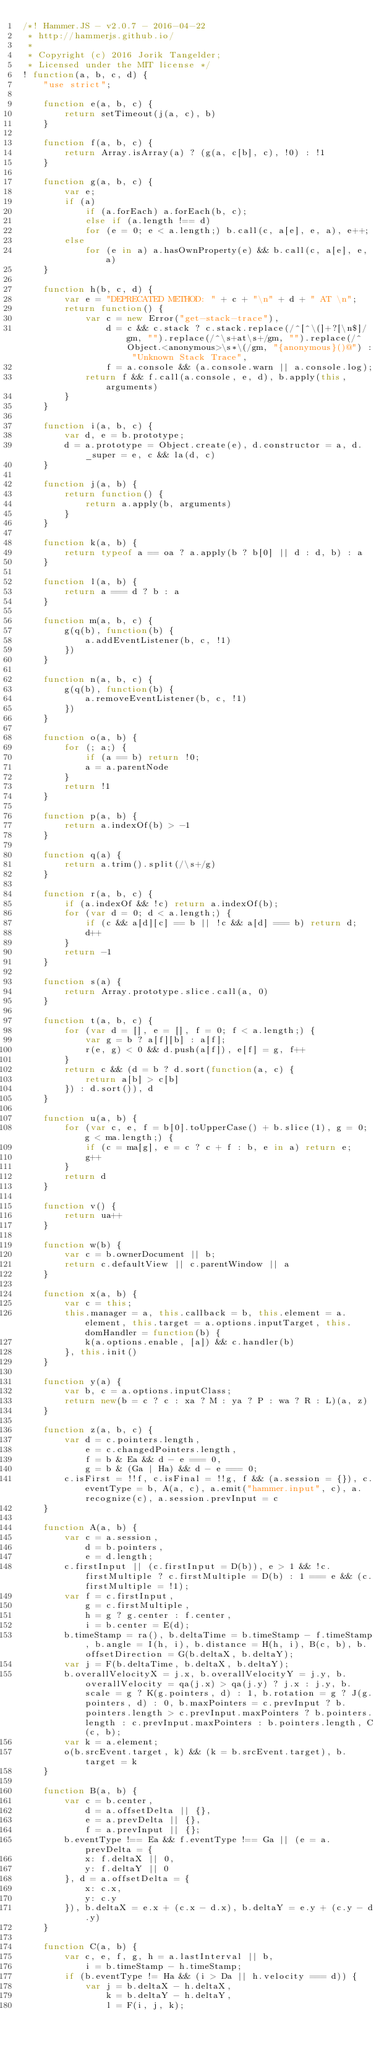<code> <loc_0><loc_0><loc_500><loc_500><_JavaScript_>/*! Hammer.JS - v2.0.7 - 2016-04-22
 * http://hammerjs.github.io/
 *
 * Copyright (c) 2016 Jorik Tangelder;
 * Licensed under the MIT license */
! function(a, b, c, d) {
    "use strict";

    function e(a, b, c) {
        return setTimeout(j(a, c), b)
    }

    function f(a, b, c) {
        return Array.isArray(a) ? (g(a, c[b], c), !0) : !1
    }

    function g(a, b, c) {
        var e;
        if (a)
            if (a.forEach) a.forEach(b, c);
            else if (a.length !== d)
            for (e = 0; e < a.length;) b.call(c, a[e], e, a), e++;
        else
            for (e in a) a.hasOwnProperty(e) && b.call(c, a[e], e, a)
    }

    function h(b, c, d) {
        var e = "DEPRECATED METHOD: " + c + "\n" + d + " AT \n";
        return function() {
            var c = new Error("get-stack-trace"),
                d = c && c.stack ? c.stack.replace(/^[^\(]+?[\n$]/gm, "").replace(/^\s+at\s+/gm, "").replace(/^Object.<anonymous>\s*\(/gm, "{anonymous}()@") : "Unknown Stack Trace",
                f = a.console && (a.console.warn || a.console.log);
            return f && f.call(a.console, e, d), b.apply(this, arguments)
        }
    }

    function i(a, b, c) {
        var d, e = b.prototype;
        d = a.prototype = Object.create(e), d.constructor = a, d._super = e, c && la(d, c)
    }

    function j(a, b) {
        return function() {
            return a.apply(b, arguments)
        }
    }

    function k(a, b) {
        return typeof a == oa ? a.apply(b ? b[0] || d : d, b) : a
    }

    function l(a, b) {
        return a === d ? b : a
    }

    function m(a, b, c) {
        g(q(b), function(b) {
            a.addEventListener(b, c, !1)
        })
    }

    function n(a, b, c) {
        g(q(b), function(b) {
            a.removeEventListener(b, c, !1)
        })
    }

    function o(a, b) {
        for (; a;) {
            if (a == b) return !0;
            a = a.parentNode
        }
        return !1
    }

    function p(a, b) {
        return a.indexOf(b) > -1
    }

    function q(a) {
        return a.trim().split(/\s+/g)
    }

    function r(a, b, c) {
        if (a.indexOf && !c) return a.indexOf(b);
        for (var d = 0; d < a.length;) {
            if (c && a[d][c] == b || !c && a[d] === b) return d;
            d++
        }
        return -1
    }

    function s(a) {
        return Array.prototype.slice.call(a, 0)
    }

    function t(a, b, c) {
        for (var d = [], e = [], f = 0; f < a.length;) {
            var g = b ? a[f][b] : a[f];
            r(e, g) < 0 && d.push(a[f]), e[f] = g, f++
        }
        return c && (d = b ? d.sort(function(a, c) {
            return a[b] > c[b]
        }) : d.sort()), d
    }

    function u(a, b) {
        for (var c, e, f = b[0].toUpperCase() + b.slice(1), g = 0; g < ma.length;) {
            if (c = ma[g], e = c ? c + f : b, e in a) return e;
            g++
        }
        return d
    }

    function v() {
        return ua++
    }

    function w(b) {
        var c = b.ownerDocument || b;
        return c.defaultView || c.parentWindow || a
    }

    function x(a, b) {
        var c = this;
        this.manager = a, this.callback = b, this.element = a.element, this.target = a.options.inputTarget, this.domHandler = function(b) {
            k(a.options.enable, [a]) && c.handler(b)
        }, this.init()
    }

    function y(a) {
        var b, c = a.options.inputClass;
        return new(b = c ? c : xa ? M : ya ? P : wa ? R : L)(a, z)
    }

    function z(a, b, c) {
        var d = c.pointers.length,
            e = c.changedPointers.length,
            f = b & Ea && d - e === 0,
            g = b & (Ga | Ha) && d - e === 0;
        c.isFirst = !!f, c.isFinal = !!g, f && (a.session = {}), c.eventType = b, A(a, c), a.emit("hammer.input", c), a.recognize(c), a.session.prevInput = c
    }

    function A(a, b) {
        var c = a.session,
            d = b.pointers,
            e = d.length;
        c.firstInput || (c.firstInput = D(b)), e > 1 && !c.firstMultiple ? c.firstMultiple = D(b) : 1 === e && (c.firstMultiple = !1);
        var f = c.firstInput,
            g = c.firstMultiple,
            h = g ? g.center : f.center,
            i = b.center = E(d);
        b.timeStamp = ra(), b.deltaTime = b.timeStamp - f.timeStamp, b.angle = I(h, i), b.distance = H(h, i), B(c, b), b.offsetDirection = G(b.deltaX, b.deltaY);
        var j = F(b.deltaTime, b.deltaX, b.deltaY);
        b.overallVelocityX = j.x, b.overallVelocityY = j.y, b.overallVelocity = qa(j.x) > qa(j.y) ? j.x : j.y, b.scale = g ? K(g.pointers, d) : 1, b.rotation = g ? J(g.pointers, d) : 0, b.maxPointers = c.prevInput ? b.pointers.length > c.prevInput.maxPointers ? b.pointers.length : c.prevInput.maxPointers : b.pointers.length, C(c, b);
        var k = a.element;
        o(b.srcEvent.target, k) && (k = b.srcEvent.target), b.target = k
    }

    function B(a, b) {
        var c = b.center,
            d = a.offsetDelta || {},
            e = a.prevDelta || {},
            f = a.prevInput || {};
        b.eventType !== Ea && f.eventType !== Ga || (e = a.prevDelta = {
            x: f.deltaX || 0,
            y: f.deltaY || 0
        }, d = a.offsetDelta = {
            x: c.x,
            y: c.y
        }), b.deltaX = e.x + (c.x - d.x), b.deltaY = e.y + (c.y - d.y)
    }

    function C(a, b) {
        var c, e, f, g, h = a.lastInterval || b,
            i = b.timeStamp - h.timeStamp;
        if (b.eventType != Ha && (i > Da || h.velocity === d)) {
            var j = b.deltaX - h.deltaX,
                k = b.deltaY - h.deltaY,
                l = F(i, j, k);</code> 